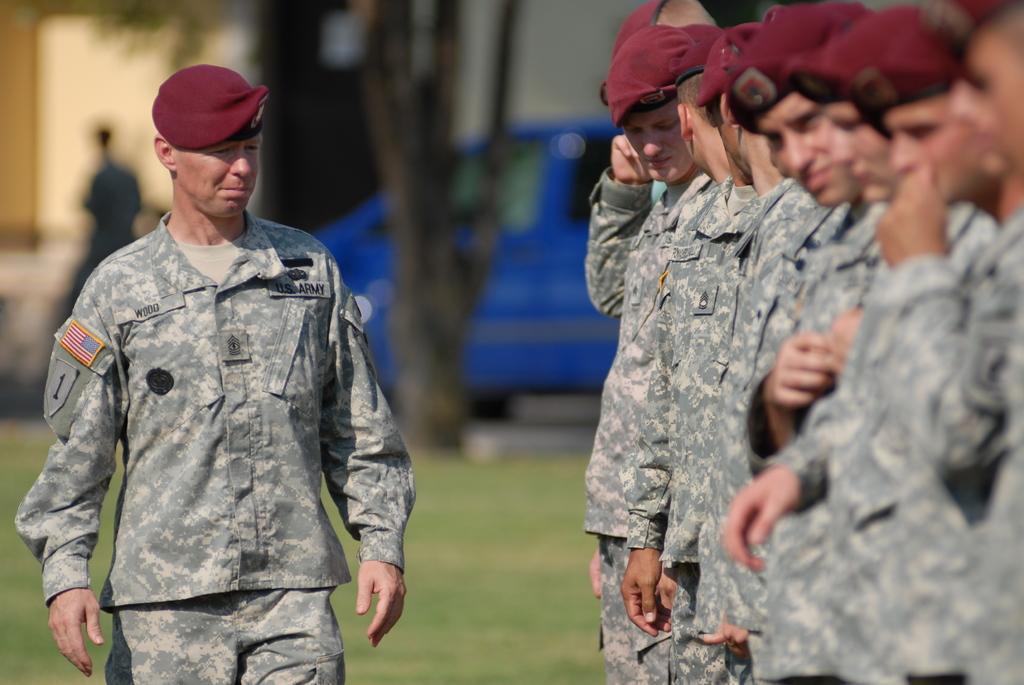In one or two sentences, can you explain what this image depicts? In the image we can see there are people standing and wearing army dress, they are wearing a cap. This is a grass and vehicle, and the background is blurred. 